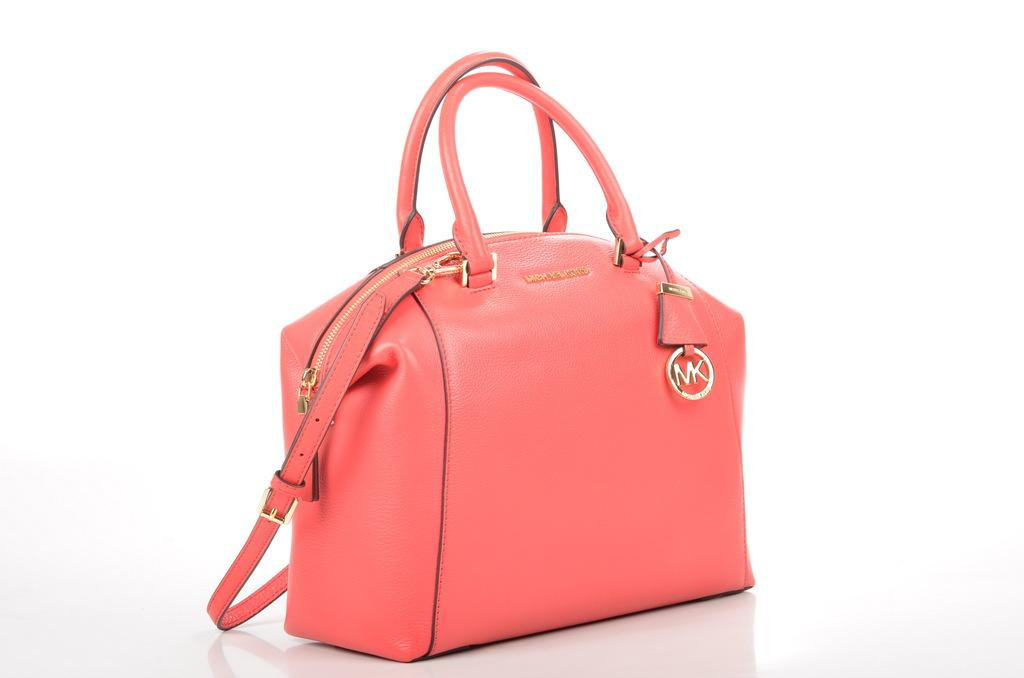What color is the handbag in the image? The handbag in the image is pink. Where is the handbag located in the image? The handbag is placed on the floor. What color is the background of the image? The background of the image is white. How does the angle of the handbag change in the image? The angle of the handbag does not change in the image; it remains stationary on the floor. 